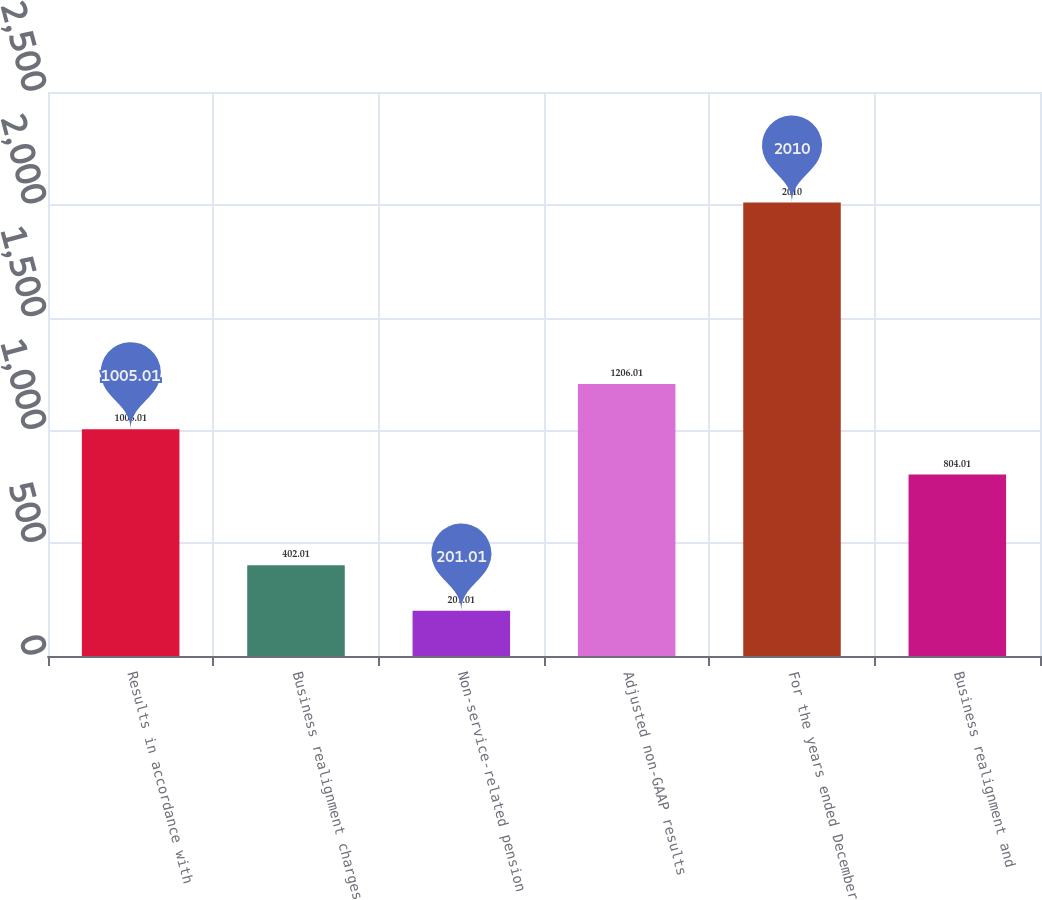<chart> <loc_0><loc_0><loc_500><loc_500><bar_chart><fcel>Results in accordance with<fcel>Business realignment charges<fcel>Non-service-related pension<fcel>Adjusted non-GAAP results<fcel>For the years ended December<fcel>Business realignment and<nl><fcel>1005.01<fcel>402.01<fcel>201.01<fcel>1206.01<fcel>2010<fcel>804.01<nl></chart> 